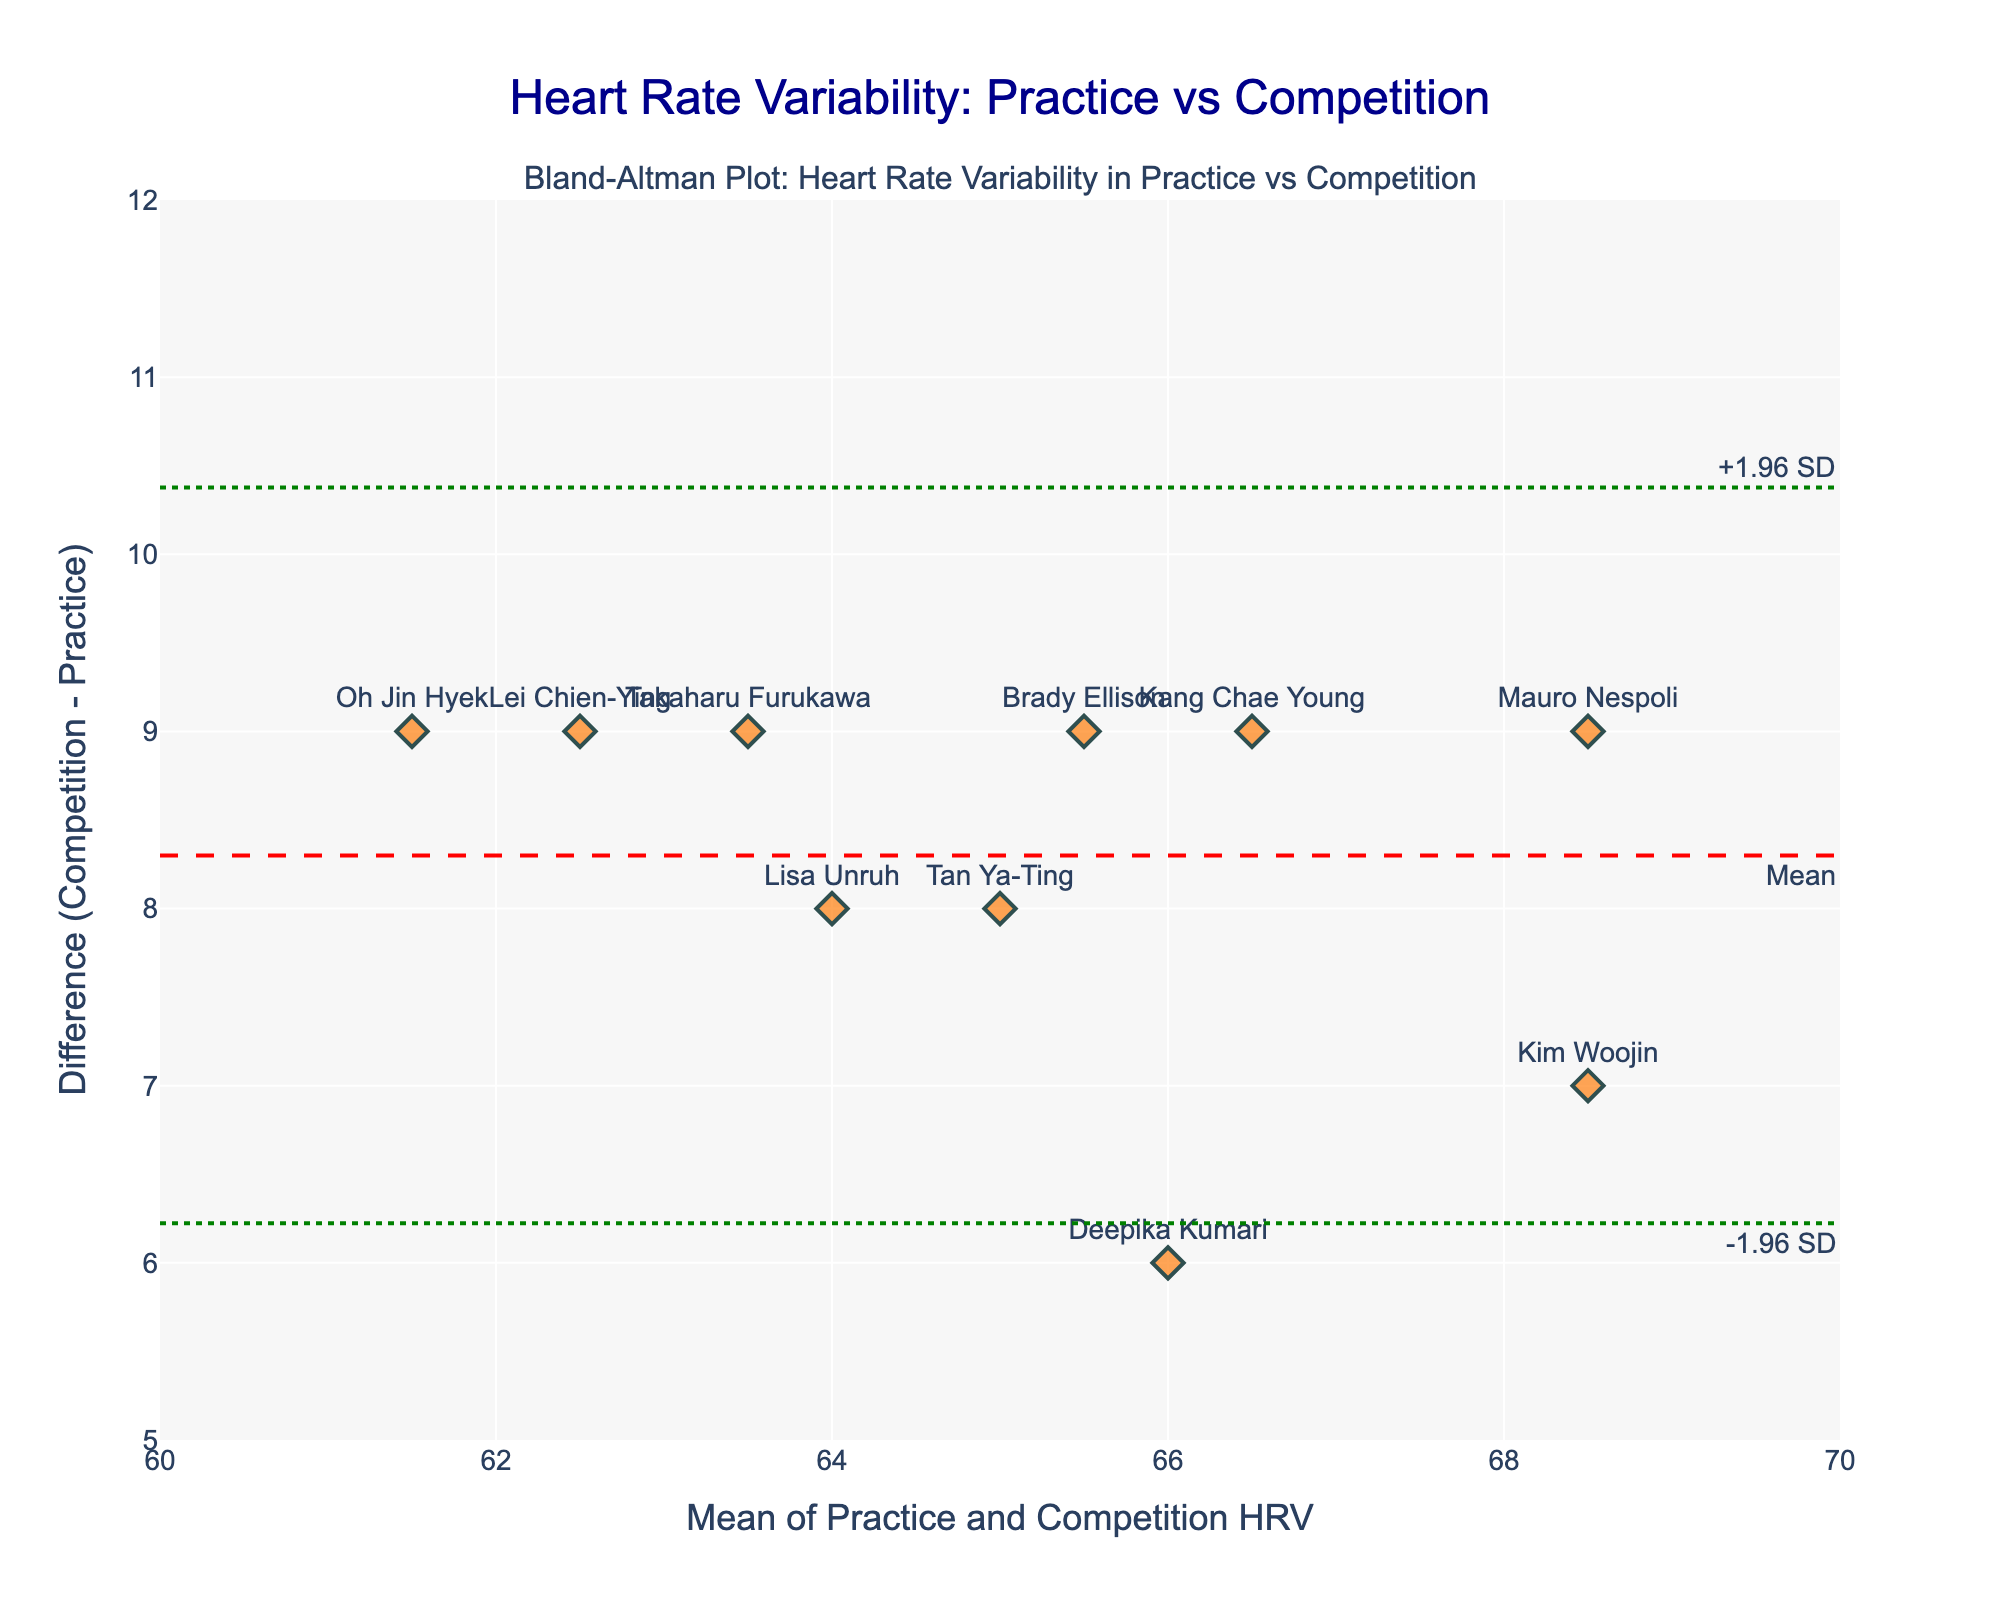what is the title of the plot? The title of the plot is located at the top center, and it is clearly stated as 'Heart Rate Variability: Practice vs Competition'.
Answer: Heart Rate Variability: Practice vs Competition How many archers' data points are plotted in the figure? By counting the number of markers (each representing an archer) on the plot, we can see that there are 10 data points for 10 archers.
Answer: 10 Which archer has the highest difference in heart rate variability between competition and practice? The archer with the highest difference can be identified by looking at the maximum y-value on the plot. The highest y-value (difference) of 9 is for Mauro Nespoli.
Answer: Mauro Nespoli What is the mean difference between practice and competition heart rate variability? The mean difference is indicated on the plot by a red dashed horizontal line marked 'Mean'. The y-coordinate of this line shows the mean difference as approximately 7.7.
Answer: 7.7 What is the range of the x-axis values? By observing the values on the x-axis, we can see it ranges from approximately 60 to 70.
Answer: 60 to 70 Where do the upper and lower limits of agreement lie on the y-axis? The plot shows green dotted lines representing the +1.96 SD and -1.96 SD lines. The coordinates of these lines indicate the limits of agreement, which are approximately 9.6 and 5.8, respectively.
Answer: 9.6 and 5.8 Calculate the average mean heart rate variability for all archers in the plot. Sum all the mean values given for the archers (68.5, 62.5, 65.5, 66, 63.5, 66.5, 61.5, 64, 68.5, 65) and divide by the number of archers (10). (68.5 + 62.5 + 65.5 + 66 + 63.5 + 66.5 + 61.5 + 64 + 68.5 + 65) / 10 = 651 / 10 = 65.1
Answer: 65.1 Which two archers have the closest mean heart rate variability values? The archers with the closest mean values have to be compared visually. By checking the x-axis values, we see that Kim Woojin and Mauro Nespoli both have a mean value of 68.5.
Answer: Kim Woojin and Mauro Nespoli Does any archer's difference in heart rate variability fall outside the limits of agreement? To determine this, observe if any data points lie outside the green dotted lines (+1.96 SD and -1.96 SD). All points fall within these lines, so no archer's difference falls outside the limits.
Answer: No What is the difference in heart rate variability for Brady Ellison? Locate Brady Ellison on the plot (marked by his name) and note the y-coordinate. This point is at 9, which represents the heart rate variability difference for Brady Ellison.
Answer: 9 